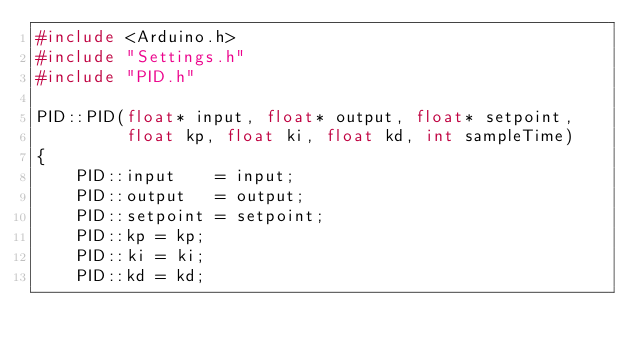Convert code to text. <code><loc_0><loc_0><loc_500><loc_500><_C++_>#include <Arduino.h>
#include "Settings.h"
#include "PID.h"

PID::PID(float* input, float* output, float* setpoint,
         float kp, float ki, float kd, int sampleTime)
{
    PID::input    = input;
    PID::output   = output;
    PID::setpoint = setpoint;
    PID::kp = kp;
    PID::ki = ki;
    PID::kd = kd;</code> 